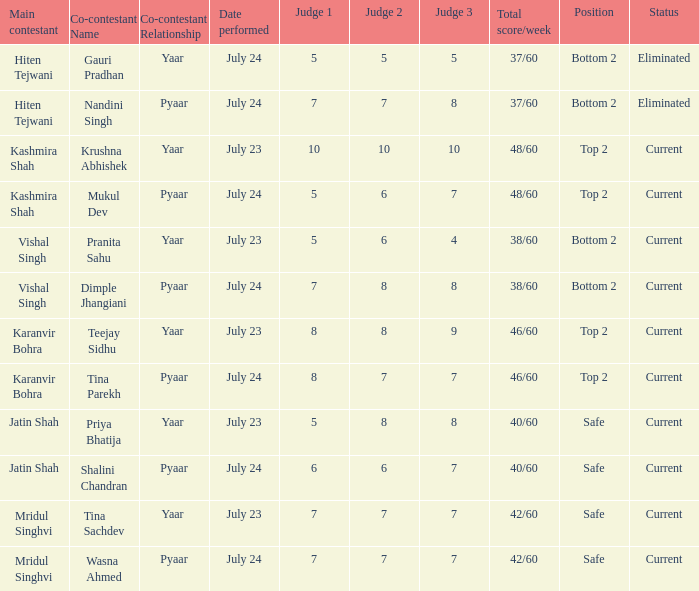Who is the co-contestant (yaar vs. Pyaar) with Vishal Singh as the main contestant? Pranita Sahu, Dimple Jhangiani. 